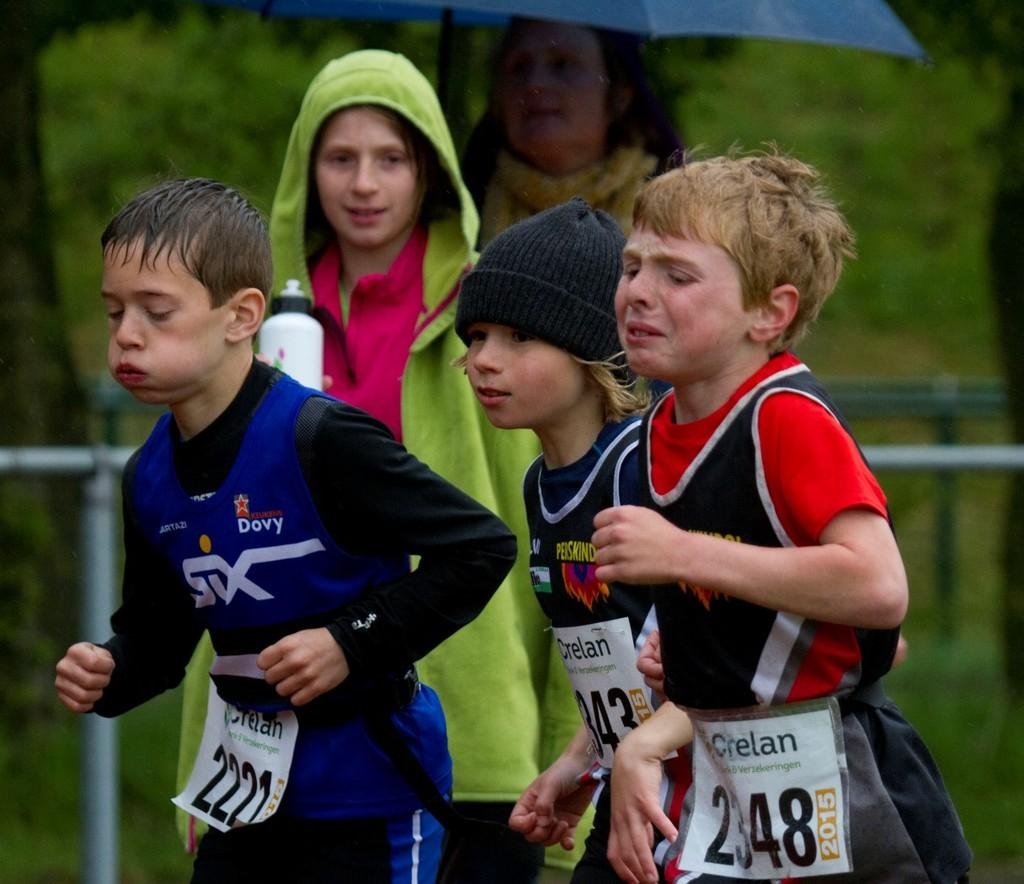How many people are in the image? There are five persons in the image. What are some of the actions being performed by the people in the image? Three of the persons are running, one person is holding an umbrella, and another person is holding a bottle. Can you describe the positioning of the person with the umbrella? The person holding the umbrella is at the top of the group. How is the person holding the bottle positioned in relation to the person with the umbrella? The person holding the bottle is in front of the person with the umbrella. How many rabbits are playing basketball in the image? There are no rabbits or basketballs present in the image. 